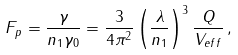Convert formula to latex. <formula><loc_0><loc_0><loc_500><loc_500>F _ { p } = \frac { \gamma } { n _ { 1 } \gamma _ { 0 } } = \frac { 3 } { 4 \pi ^ { 2 } } \left ( \frac { \lambda } { n _ { 1 } } \right ) ^ { 3 } \frac { Q } { V _ { e f f } } \, ,</formula> 